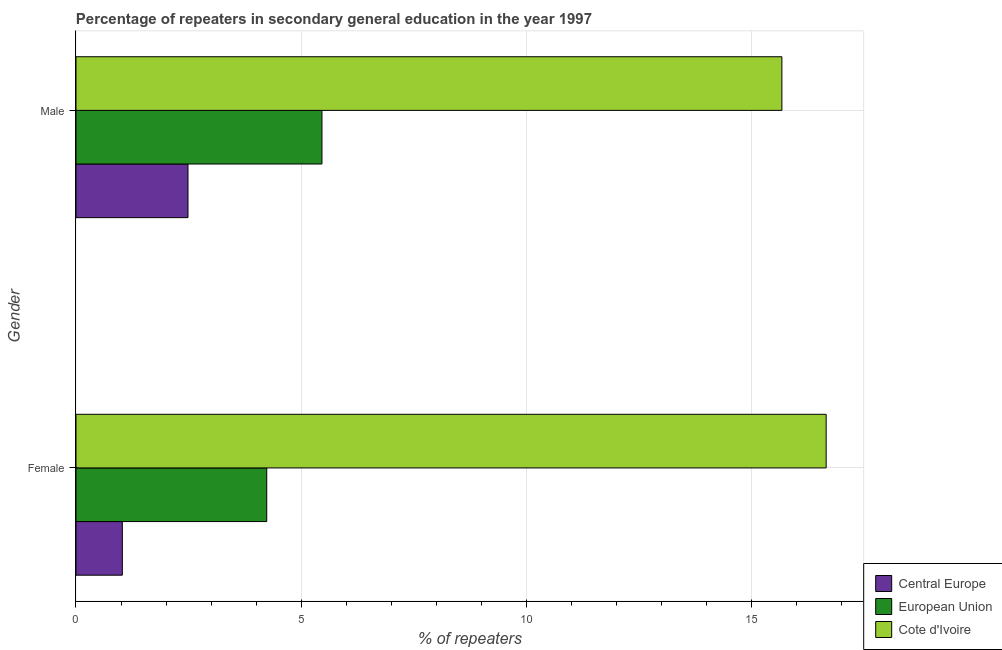How many different coloured bars are there?
Make the answer very short. 3. Are the number of bars per tick equal to the number of legend labels?
Ensure brevity in your answer.  Yes. How many bars are there on the 1st tick from the bottom?
Make the answer very short. 3. What is the label of the 1st group of bars from the top?
Offer a very short reply. Male. What is the percentage of female repeaters in European Union?
Make the answer very short. 4.24. Across all countries, what is the maximum percentage of male repeaters?
Offer a terse response. 15.69. Across all countries, what is the minimum percentage of male repeaters?
Your answer should be very brief. 2.49. In which country was the percentage of male repeaters maximum?
Provide a succinct answer. Cote d'Ivoire. In which country was the percentage of female repeaters minimum?
Keep it short and to the point. Central Europe. What is the total percentage of female repeaters in the graph?
Your response must be concise. 21.94. What is the difference between the percentage of male repeaters in Central Europe and that in European Union?
Make the answer very short. -2.98. What is the difference between the percentage of female repeaters in European Union and the percentage of male repeaters in Cote d'Ivoire?
Offer a very short reply. -11.45. What is the average percentage of male repeaters per country?
Offer a very short reply. 7.88. What is the difference between the percentage of male repeaters and percentage of female repeaters in European Union?
Your answer should be very brief. 1.23. What is the ratio of the percentage of male repeaters in Cote d'Ivoire to that in European Union?
Keep it short and to the point. 2.87. Is the percentage of female repeaters in European Union less than that in Central Europe?
Offer a terse response. No. What does the 1st bar from the top in Female represents?
Ensure brevity in your answer.  Cote d'Ivoire. What does the 3rd bar from the bottom in Male represents?
Your answer should be very brief. Cote d'Ivoire. How many bars are there?
Your answer should be very brief. 6. How many countries are there in the graph?
Your answer should be very brief. 3. Are the values on the major ticks of X-axis written in scientific E-notation?
Your response must be concise. No. Does the graph contain any zero values?
Make the answer very short. No. Where does the legend appear in the graph?
Give a very brief answer. Bottom right. How many legend labels are there?
Your response must be concise. 3. How are the legend labels stacked?
Your response must be concise. Vertical. What is the title of the graph?
Your answer should be compact. Percentage of repeaters in secondary general education in the year 1997. Does "Singapore" appear as one of the legend labels in the graph?
Give a very brief answer. No. What is the label or title of the X-axis?
Give a very brief answer. % of repeaters. What is the label or title of the Y-axis?
Ensure brevity in your answer.  Gender. What is the % of repeaters of Central Europe in Female?
Provide a succinct answer. 1.03. What is the % of repeaters in European Union in Female?
Keep it short and to the point. 4.24. What is the % of repeaters of Cote d'Ivoire in Female?
Offer a terse response. 16.67. What is the % of repeaters of Central Europe in Male?
Your answer should be very brief. 2.49. What is the % of repeaters in European Union in Male?
Provide a short and direct response. 5.47. What is the % of repeaters in Cote d'Ivoire in Male?
Offer a terse response. 15.69. Across all Gender, what is the maximum % of repeaters of Central Europe?
Your answer should be very brief. 2.49. Across all Gender, what is the maximum % of repeaters of European Union?
Give a very brief answer. 5.47. Across all Gender, what is the maximum % of repeaters in Cote d'Ivoire?
Your answer should be very brief. 16.67. Across all Gender, what is the minimum % of repeaters of Central Europe?
Keep it short and to the point. 1.03. Across all Gender, what is the minimum % of repeaters of European Union?
Your answer should be compact. 4.24. Across all Gender, what is the minimum % of repeaters in Cote d'Ivoire?
Your answer should be compact. 15.69. What is the total % of repeaters in Central Europe in the graph?
Offer a very short reply. 3.52. What is the total % of repeaters of European Union in the graph?
Your answer should be compact. 9.7. What is the total % of repeaters in Cote d'Ivoire in the graph?
Your response must be concise. 32.35. What is the difference between the % of repeaters of Central Europe in Female and that in Male?
Keep it short and to the point. -1.46. What is the difference between the % of repeaters of European Union in Female and that in Male?
Your answer should be very brief. -1.23. What is the difference between the % of repeaters of Cote d'Ivoire in Female and that in Male?
Provide a succinct answer. 0.98. What is the difference between the % of repeaters in Central Europe in Female and the % of repeaters in European Union in Male?
Your answer should be very brief. -4.44. What is the difference between the % of repeaters in Central Europe in Female and the % of repeaters in Cote d'Ivoire in Male?
Keep it short and to the point. -14.66. What is the difference between the % of repeaters of European Union in Female and the % of repeaters of Cote d'Ivoire in Male?
Your answer should be compact. -11.45. What is the average % of repeaters of Central Europe per Gender?
Your answer should be very brief. 1.76. What is the average % of repeaters in European Union per Gender?
Your response must be concise. 4.85. What is the average % of repeaters of Cote d'Ivoire per Gender?
Your answer should be compact. 16.18. What is the difference between the % of repeaters in Central Europe and % of repeaters in European Union in Female?
Offer a very short reply. -3.21. What is the difference between the % of repeaters of Central Europe and % of repeaters of Cote d'Ivoire in Female?
Offer a very short reply. -15.64. What is the difference between the % of repeaters in European Union and % of repeaters in Cote d'Ivoire in Female?
Provide a succinct answer. -12.43. What is the difference between the % of repeaters of Central Europe and % of repeaters of European Union in Male?
Offer a terse response. -2.98. What is the difference between the % of repeaters in Central Europe and % of repeaters in Cote d'Ivoire in Male?
Offer a terse response. -13.2. What is the difference between the % of repeaters of European Union and % of repeaters of Cote d'Ivoire in Male?
Provide a short and direct response. -10.22. What is the ratio of the % of repeaters of Central Europe in Female to that in Male?
Make the answer very short. 0.41. What is the ratio of the % of repeaters in European Union in Female to that in Male?
Your response must be concise. 0.78. What is the ratio of the % of repeaters of Cote d'Ivoire in Female to that in Male?
Your answer should be compact. 1.06. What is the difference between the highest and the second highest % of repeaters of Central Europe?
Provide a succinct answer. 1.46. What is the difference between the highest and the second highest % of repeaters of European Union?
Provide a succinct answer. 1.23. What is the difference between the highest and the second highest % of repeaters in Cote d'Ivoire?
Offer a very short reply. 0.98. What is the difference between the highest and the lowest % of repeaters of Central Europe?
Make the answer very short. 1.46. What is the difference between the highest and the lowest % of repeaters of European Union?
Provide a short and direct response. 1.23. 